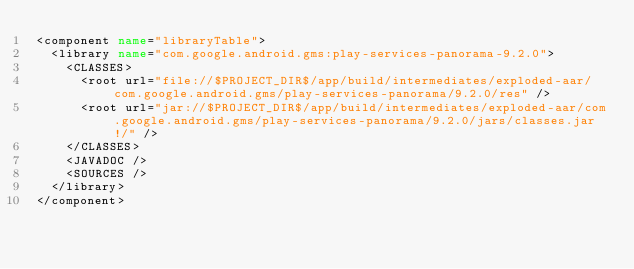Convert code to text. <code><loc_0><loc_0><loc_500><loc_500><_XML_><component name="libraryTable">
  <library name="com.google.android.gms:play-services-panorama-9.2.0">
    <CLASSES>
      <root url="file://$PROJECT_DIR$/app/build/intermediates/exploded-aar/com.google.android.gms/play-services-panorama/9.2.0/res" />
      <root url="jar://$PROJECT_DIR$/app/build/intermediates/exploded-aar/com.google.android.gms/play-services-panorama/9.2.0/jars/classes.jar!/" />
    </CLASSES>
    <JAVADOC />
    <SOURCES />
  </library>
</component></code> 